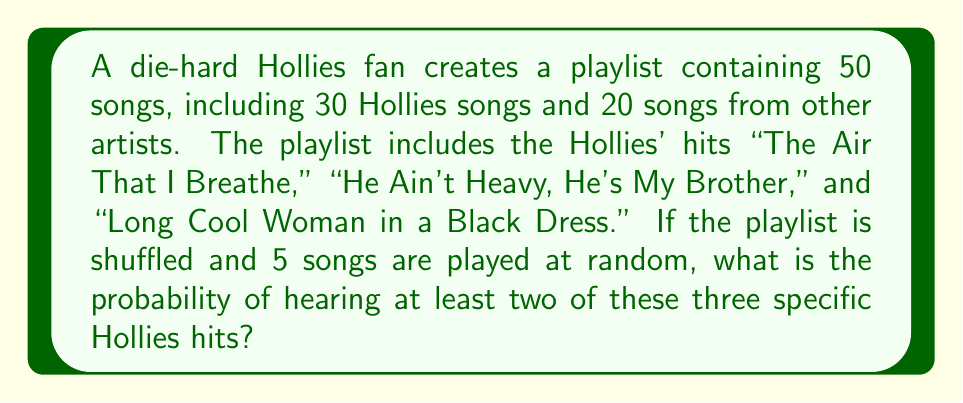What is the answer to this math problem? Let's approach this step-by-step using the complement method:

1) First, we'll calculate the probability of hearing fewer than two of the specific hits.

2) There are $\binom{50}{5}$ ways to choose 5 songs from 50.

3) To have fewer than two specific hits, we can have either zero or one:

   a) Zero hits: Choose all 5 from the other 47 songs: $\binom{47}{5}$
   b) One hit: Choose 1 from the 3 hits and 4 from the other 47: $\binom{3}{1} \cdot \binom{47}{4}$

4) Total favorable outcomes for fewer than two hits:
   $$\binom{47}{5} + \binom{3}{1} \cdot \binom{47}{4}$$

5) Probability of fewer than two hits:
   $$P(\text{fewer than two}) = \frac{\binom{47}{5} + \binom{3}{1} \cdot \binom{47}{4}}{\binom{50}{5}}$$

6) Therefore, the probability of at least two hits is:
   $$P(\text{at least two}) = 1 - P(\text{fewer than two})$$
   $$= 1 - \frac{\binom{47}{5} + \binom{3}{1} \cdot \binom{47}{4}}{\binom{50}{5}}$$

7) Calculating:
   $$= 1 - \frac{1,533,939 + 3 \cdot 178,365}{2,118,760}$$
   $$= 1 - \frac{2,069,034}{2,118,760}$$
   $$= \frac{49,726}{2,118,760}$$
   $$\approx 0.0235$$
Answer: $\frac{49,726}{2,118,760} \approx 0.0235$ or about 2.35% 